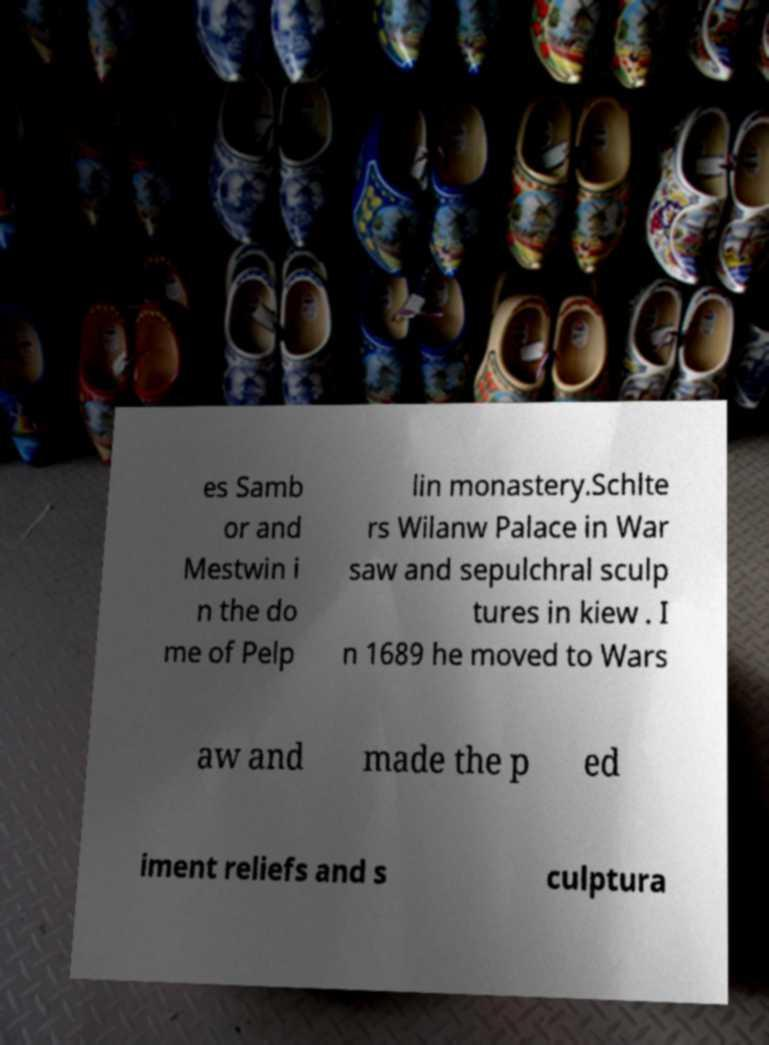There's text embedded in this image that I need extracted. Can you transcribe it verbatim? es Samb or and Mestwin i n the do me of Pelp lin monastery.Schlte rs Wilanw Palace in War saw and sepulchral sculp tures in kiew . I n 1689 he moved to Wars aw and made the p ed iment reliefs and s culptura 